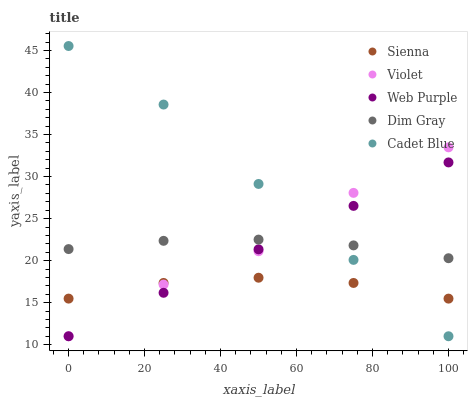Does Sienna have the minimum area under the curve?
Answer yes or no. Yes. Does Cadet Blue have the maximum area under the curve?
Answer yes or no. Yes. Does Web Purple have the minimum area under the curve?
Answer yes or no. No. Does Web Purple have the maximum area under the curve?
Answer yes or no. No. Is Web Purple the smoothest?
Answer yes or no. Yes. Is Violet the roughest?
Answer yes or no. Yes. Is Dim Gray the smoothest?
Answer yes or no. No. Is Dim Gray the roughest?
Answer yes or no. No. Does Web Purple have the lowest value?
Answer yes or no. Yes. Does Dim Gray have the lowest value?
Answer yes or no. No. Does Cadet Blue have the highest value?
Answer yes or no. Yes. Does Web Purple have the highest value?
Answer yes or no. No. Is Sienna less than Dim Gray?
Answer yes or no. Yes. Is Dim Gray greater than Sienna?
Answer yes or no. Yes. Does Dim Gray intersect Web Purple?
Answer yes or no. Yes. Is Dim Gray less than Web Purple?
Answer yes or no. No. Is Dim Gray greater than Web Purple?
Answer yes or no. No. Does Sienna intersect Dim Gray?
Answer yes or no. No. 